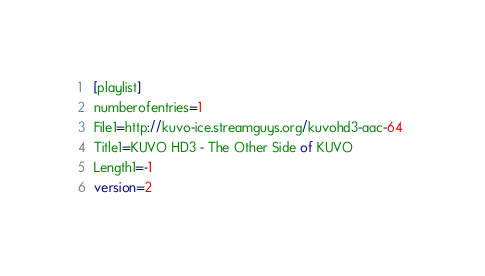Convert code to text. <code><loc_0><loc_0><loc_500><loc_500><_SQL_>[playlist]
numberofentries=1
File1=http://kuvo-ice.streamguys.org/kuvohd3-aac-64 
Title1=KUVO HD3 - The Other Side of KUVO
Length1=-1
version=2
</code> 